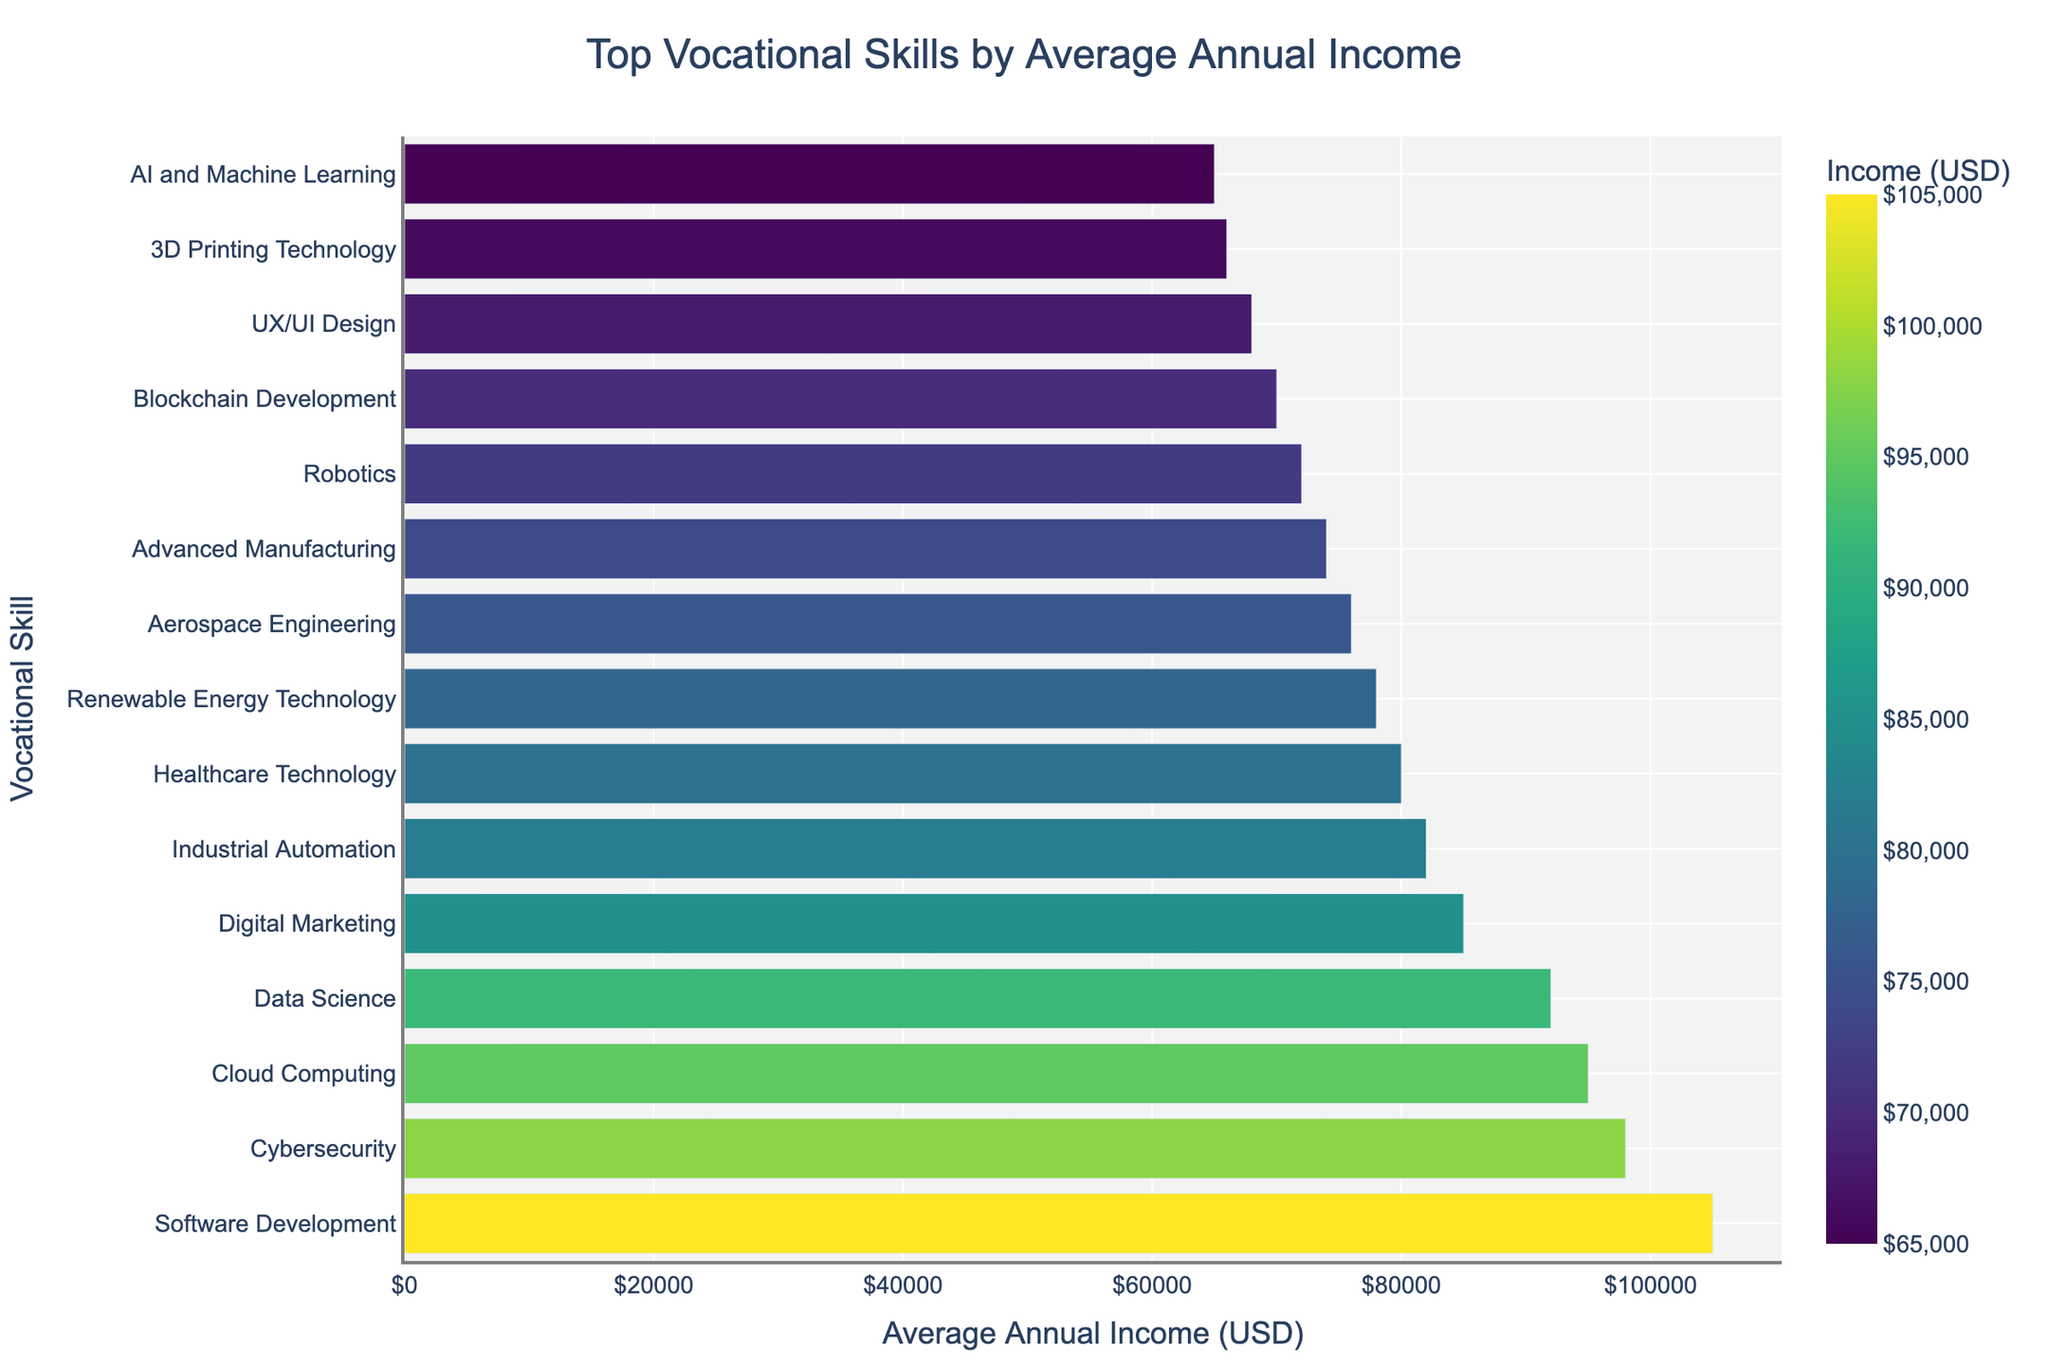Which vocational skill has the highest average annual income? Look at the top of the bar chart, where the longest bar is displayed. This bar corresponds to "Software Development" with an average annual income of $105,000.
Answer: Software Development What is the difference in average annual income between Data Science and Digital Marketing? Identify the bars representing Data Science and Digital Marketing. Data Science has an average annual income of $92,000, while Digital Marketing has $85,000. Subtract the latter from the former: $92,000 - $85,000 = $7,000.
Answer: $7,000 Which skill has a lower average annual income: Industrial Automation or Renewable Energy Technology? Identify the bars corresponding to Industrial Automation and Renewable Energy Technology. Industrial Automation has an average annual income of $82,000, and Renewable Energy Technology has $78,000. Compare the two amounts.
Answer: Renewable Energy Technology How much more does a Cybersecurity professional make compared to a Robotics professional annually? Find the bar representing Cybersecurity and the one for Robotics. The average annual income for Cybersecurity is $98,000, while for Robotics, it is $72,000. Subtract the latter from the former: $98,000 - $72,000 = $26,000.
Answer: $26,000 What is the combined average annual income of Cloud Computing and AI and Machine Learning? Locate the Cloud Computing and AI and Machine Learning bars. Cloud Computing has an average annual income of $95,000, and AI and Machine Learning has $65,000. Add these values: $95,000 + $65,000 = $160,000.
Answer: $160,000 Which skill associated with technology has the lowest average annual income? Among the bars related to technology skills, look for the shortest bar. The shortest bar among these is AI and Machine Learning, with an average annual income of $65,000.
Answer: AI and Machine Learning Between Healthcare Technology and Aerospace Engineering, which has a higher average annual income, and by how much? Identify the bars for Healthcare Technology and Aerospace Engineering. Healthcare Technology has an average annual income of $80,000, and Aerospace Engineering has $76,000. Subtract the latter from the former: $80,000 - $76,000 = $4,000.
Answer: Healthcare Technology, $4,000 How does the average annual income of Blockchain Development compare to that of UX/UI Design? Locate the bars for Blockchain Development and UX/UI Design. Blockchain Development has an average annual income of $70,000, while UX/UI Design has $68,000. Blockchain Development makes $2,000 more annually than UX/UI Design.
Answer: Blockchain Development, $2,000 What is the average (mean) annual income of the top 5 vocational skills? Find the bars for the top 5 vocational skills: Software Development ($105,000), Cybersecurity ($98,000), Cloud Computing ($95,000), Data Science ($92,000), and Digital Marketing ($85,000). Sum these amounts and then divide by 5: ($105,000 + $98,000 + $95,000 + $92,000 + $85,000) / 5 = $475,000 / 5 = $95,000.
Answer: $95,000 Which vocational skills have an average annual income greater than $80,000? Identify all bars with values above $80,000: Software Development ($105,000), Cybersecurity ($98,000), Cloud Computing ($95,000), Data Science ($92,000), Digital Marketing ($85,000), and Industrial Automation ($82,000).
Answer: Software Development, Cybersecurity, Cloud Computing, Data Science, Digital Marketing, Industrial Automation 